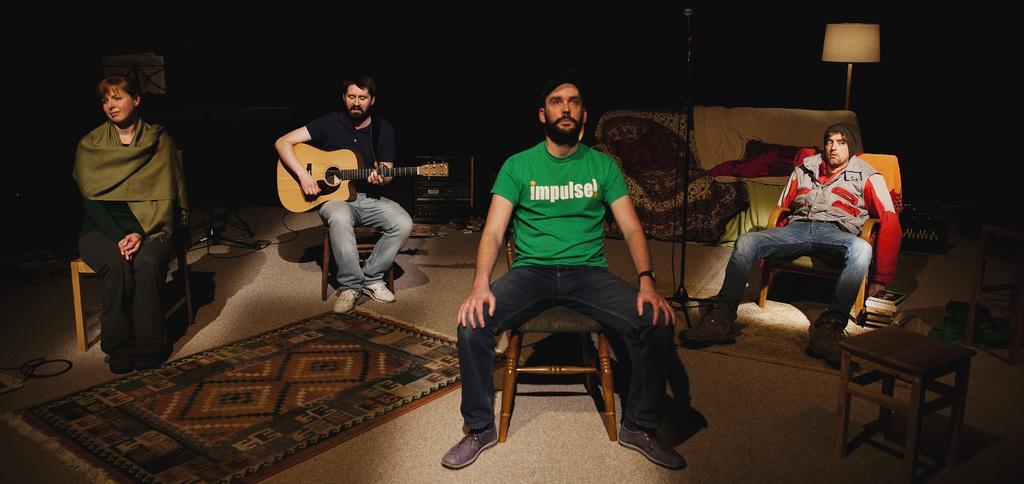Please provide a concise description of this image. In this picture there are four persons sitting on chairs. There are two persons towards the left and two persons towards the right. To the left corner, there is a woman wearing a black dress and green scarf. Besides her, there is another man, he is wearing a black t shirt and holding a guitar. In the center, there is another man, he is wearing a green t shirt and blue jeans. Towards the right corner there is a man , he is wearing a grey jacket and blue jeans. Towards the right bottom there is a table. Towards the right there is a lamp and a sofa. 